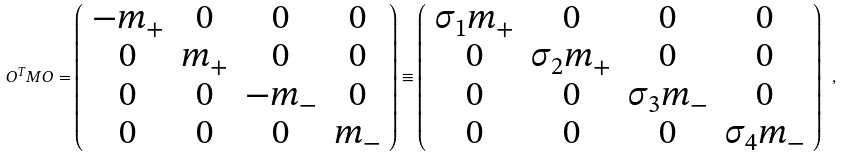Convert formula to latex. <formula><loc_0><loc_0><loc_500><loc_500>O ^ { T } M O = \left ( \begin{array} { c c c c } { { - m _ { + } } } & { 0 } & { 0 } & { 0 } \\ { 0 } & { { m _ { + } } } & { 0 } & { 0 } \\ { 0 } & { 0 } & { { - m _ { - } } } & { 0 } \\ { 0 } & { 0 } & { 0 } & { { m _ { - } } } \end{array} \right ) \equiv \left ( \begin{array} { c c c c } { { \sigma _ { 1 } m _ { + } } } & { 0 } & { 0 } & { 0 } \\ { 0 } & { { \sigma _ { 2 } m _ { + } } } & { 0 } & { 0 } \\ { 0 } & { 0 } & { { \sigma _ { 3 } m _ { - } } } & { 0 } \\ { 0 } & { 0 } & { 0 } & { { \sigma _ { 4 } m _ { - } } } \end{array} \right ) \ ,</formula> 